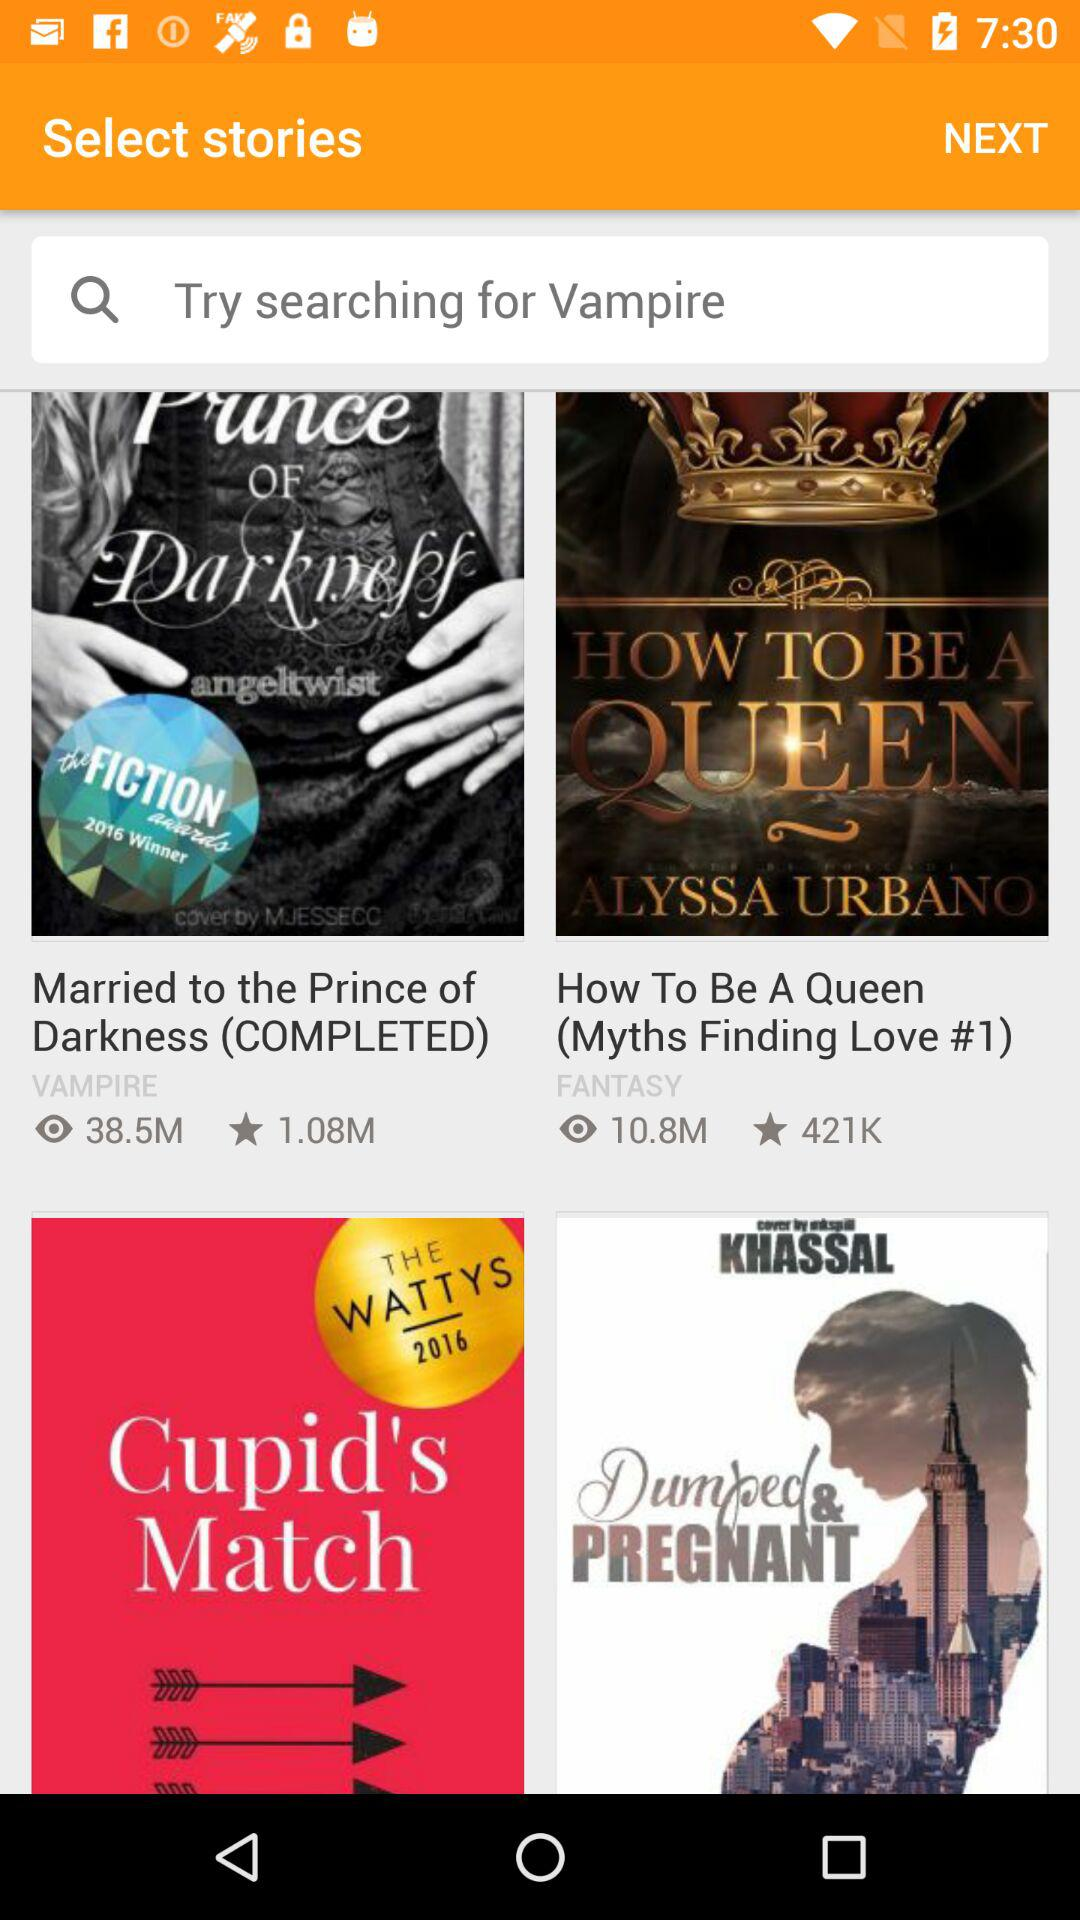How many more views does the first story have than the second?
Answer the question using a single word or phrase. 27.7M 